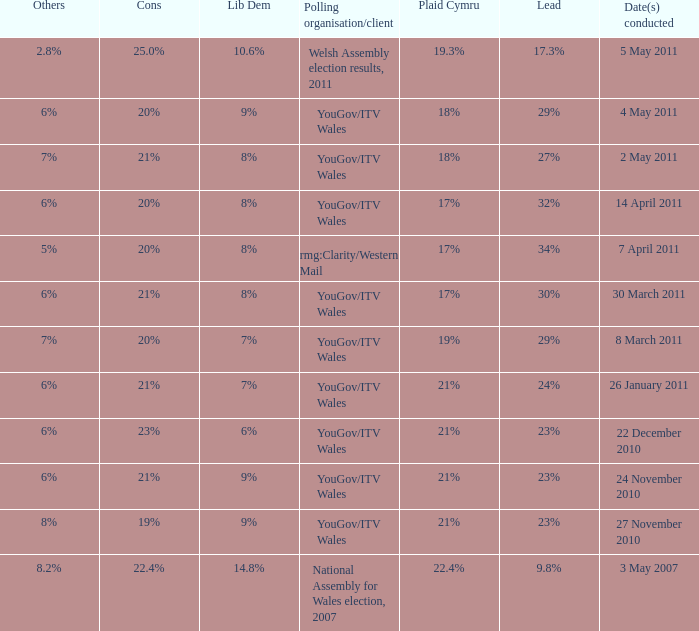Could you parse the entire table? {'header': ['Others', 'Cons', 'Lib Dem', 'Polling organisation/client', 'Plaid Cymru', 'Lead', 'Date(s) conducted'], 'rows': [['2.8%', '25.0%', '10.6%', 'Welsh Assembly election results, 2011', '19.3%', '17.3%', '5 May 2011'], ['6%', '20%', '9%', 'YouGov/ITV Wales', '18%', '29%', '4 May 2011'], ['7%', '21%', '8%', 'YouGov/ITV Wales', '18%', '27%', '2 May 2011'], ['6%', '20%', '8%', 'YouGov/ITV Wales', '17%', '32%', '14 April 2011'], ['5%', '20%', '8%', 'rmg:Clarity/Western Mail', '17%', '34%', '7 April 2011'], ['6%', '21%', '8%', 'YouGov/ITV Wales', '17%', '30%', '30 March 2011'], ['7%', '20%', '7%', 'YouGov/ITV Wales', '19%', '29%', '8 March 2011'], ['6%', '21%', '7%', 'YouGov/ITV Wales', '21%', '24%', '26 January 2011'], ['6%', '23%', '6%', 'YouGov/ITV Wales', '21%', '23%', '22 December 2010'], ['6%', '21%', '9%', 'YouGov/ITV Wales', '21%', '23%', '24 November 2010'], ['8%', '19%', '9%', 'YouGov/ITV Wales', '21%', '23%', '27 November 2010'], ['8.2%', '22.4%', '14.8%', 'National Assembly for Wales election, 2007', '22.4%', '9.8%', '3 May 2007']]} I want the lead for others being 5% 34%. 